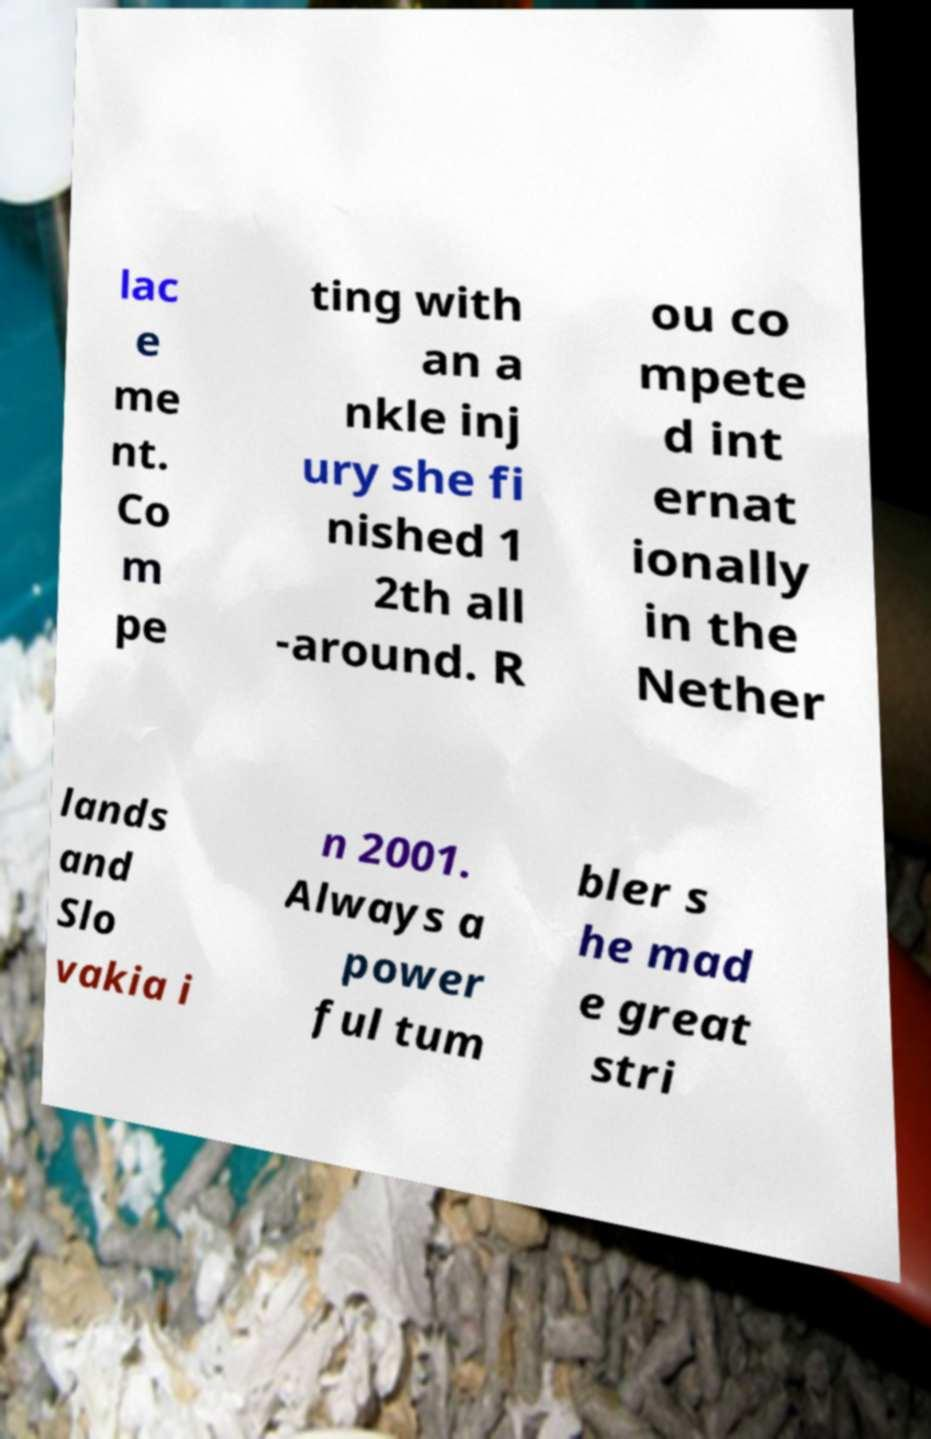What messages or text are displayed in this image? I need them in a readable, typed format. lac e me nt. Co m pe ting with an a nkle inj ury she fi nished 1 2th all -around. R ou co mpete d int ernat ionally in the Nether lands and Slo vakia i n 2001. Always a power ful tum bler s he mad e great stri 